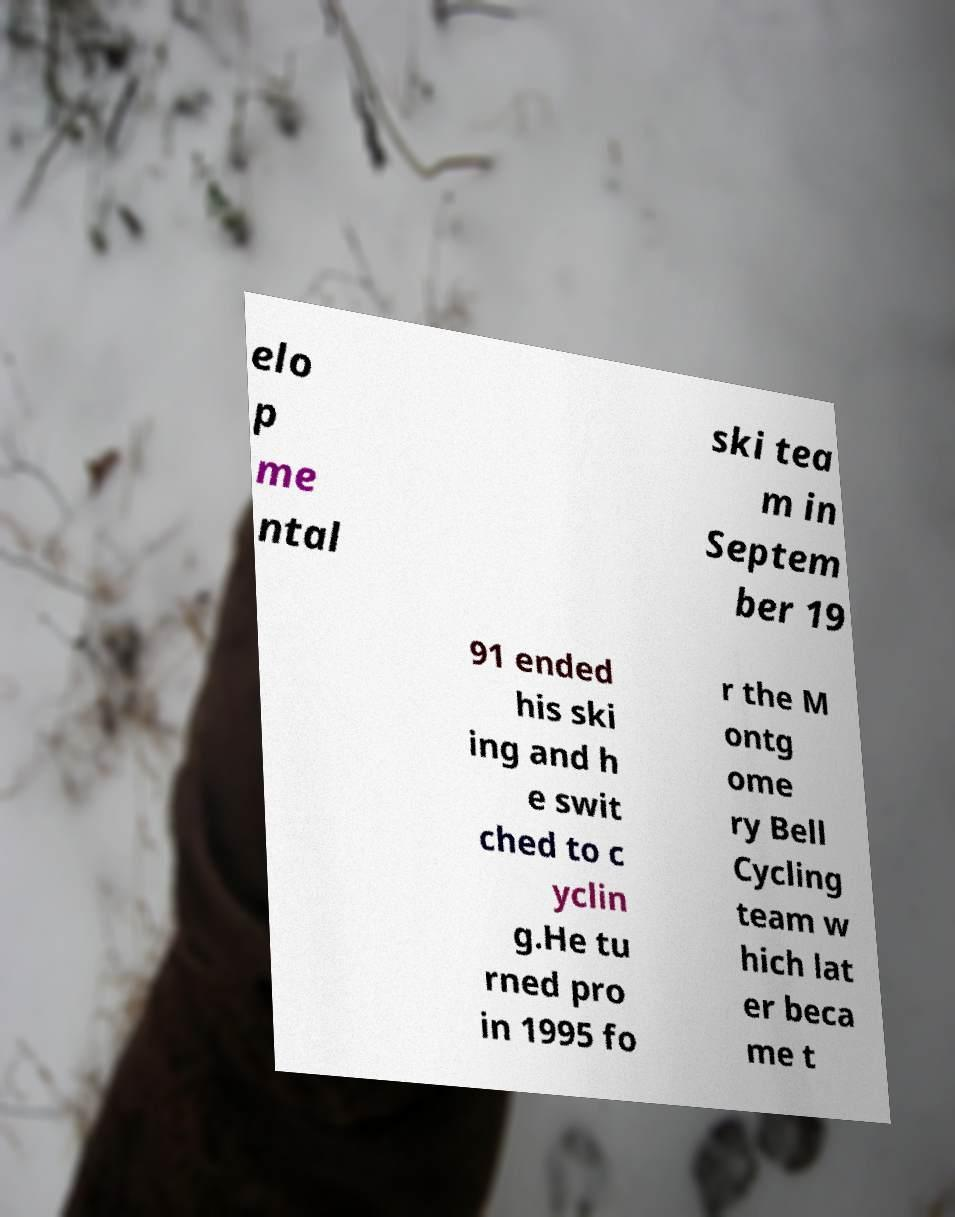Can you read and provide the text displayed in the image?This photo seems to have some interesting text. Can you extract and type it out for me? elo p me ntal ski tea m in Septem ber 19 91 ended his ski ing and h e swit ched to c yclin g.He tu rned pro in 1995 fo r the M ontg ome ry Bell Cycling team w hich lat er beca me t 